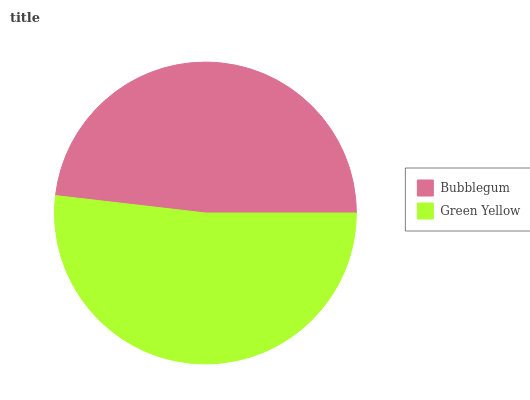Is Bubblegum the minimum?
Answer yes or no. Yes. Is Green Yellow the maximum?
Answer yes or no. Yes. Is Green Yellow the minimum?
Answer yes or no. No. Is Green Yellow greater than Bubblegum?
Answer yes or no. Yes. Is Bubblegum less than Green Yellow?
Answer yes or no. Yes. Is Bubblegum greater than Green Yellow?
Answer yes or no. No. Is Green Yellow less than Bubblegum?
Answer yes or no. No. Is Green Yellow the high median?
Answer yes or no. Yes. Is Bubblegum the low median?
Answer yes or no. Yes. Is Bubblegum the high median?
Answer yes or no. No. Is Green Yellow the low median?
Answer yes or no. No. 